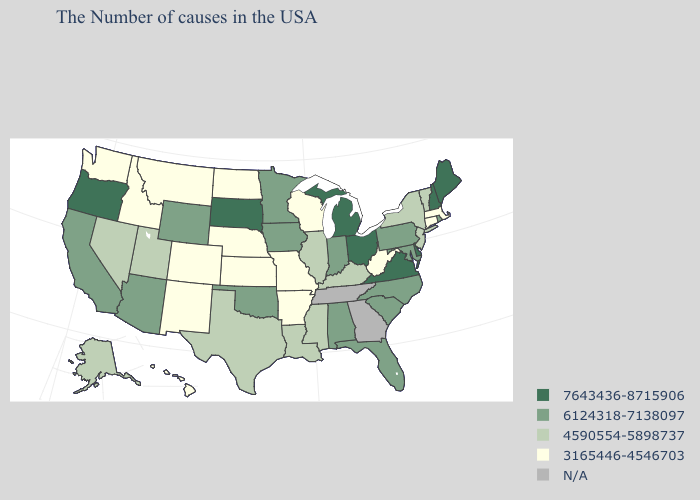Name the states that have a value in the range 3165446-4546703?
Short answer required. Massachusetts, Connecticut, West Virginia, Wisconsin, Missouri, Arkansas, Kansas, Nebraska, North Dakota, Colorado, New Mexico, Montana, Idaho, Washington, Hawaii. Among the states that border Mississippi , which have the lowest value?
Be succinct. Arkansas. What is the lowest value in the USA?
Write a very short answer. 3165446-4546703. Does Louisiana have the lowest value in the USA?
Concise answer only. No. Is the legend a continuous bar?
Answer briefly. No. What is the value of Wisconsin?
Answer briefly. 3165446-4546703. Among the states that border Missouri , which have the highest value?
Write a very short answer. Iowa, Oklahoma. Does the map have missing data?
Answer briefly. Yes. What is the value of Maryland?
Be succinct. 6124318-7138097. Among the states that border South Dakota , does Montana have the lowest value?
Concise answer only. Yes. Name the states that have a value in the range N/A?
Be succinct. Georgia, Tennessee. Does Ohio have the highest value in the MidWest?
Concise answer only. Yes. Does Utah have the lowest value in the West?
Be succinct. No. Which states hav the highest value in the MidWest?
Short answer required. Ohio, Michigan, South Dakota. Does the first symbol in the legend represent the smallest category?
Be succinct. No. 